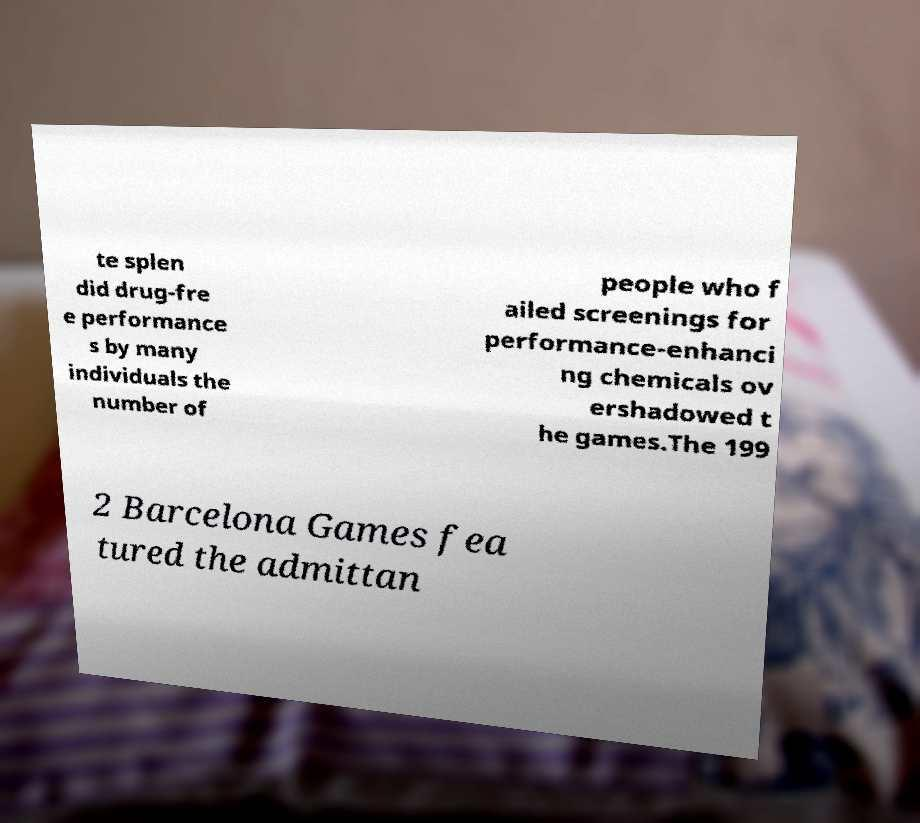There's text embedded in this image that I need extracted. Can you transcribe it verbatim? te splen did drug-fre e performance s by many individuals the number of people who f ailed screenings for performance-enhanci ng chemicals ov ershadowed t he games.The 199 2 Barcelona Games fea tured the admittan 